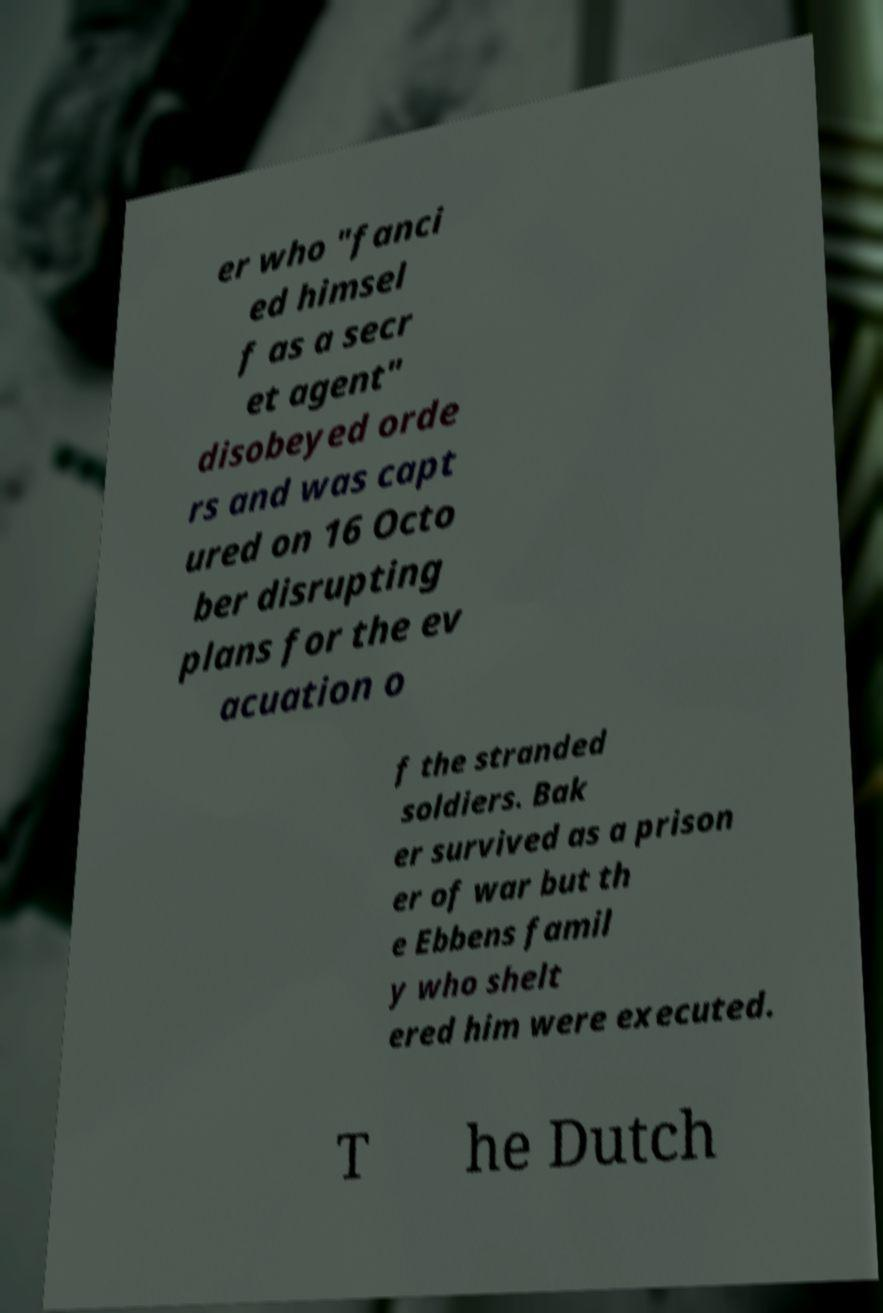What messages or text are displayed in this image? I need them in a readable, typed format. er who "fanci ed himsel f as a secr et agent" disobeyed orde rs and was capt ured on 16 Octo ber disrupting plans for the ev acuation o f the stranded soldiers. Bak er survived as a prison er of war but th e Ebbens famil y who shelt ered him were executed. T he Dutch 